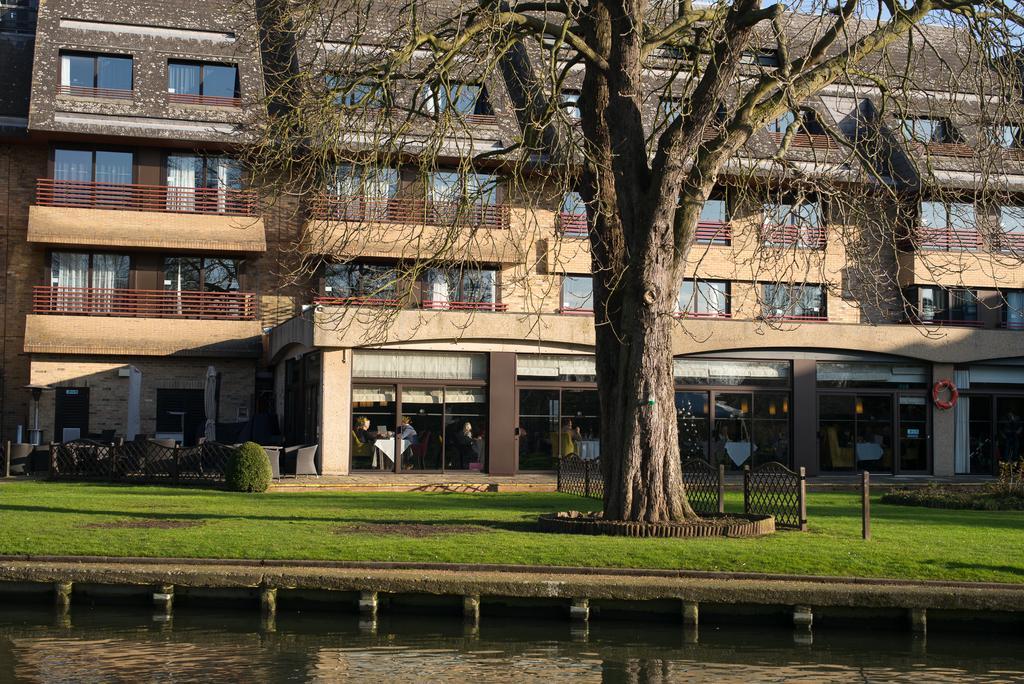Describe this image in one or two sentences. In this image I can see water, background I can see a building in cream color, trees and grass in green color, I can also see few glass windows. 